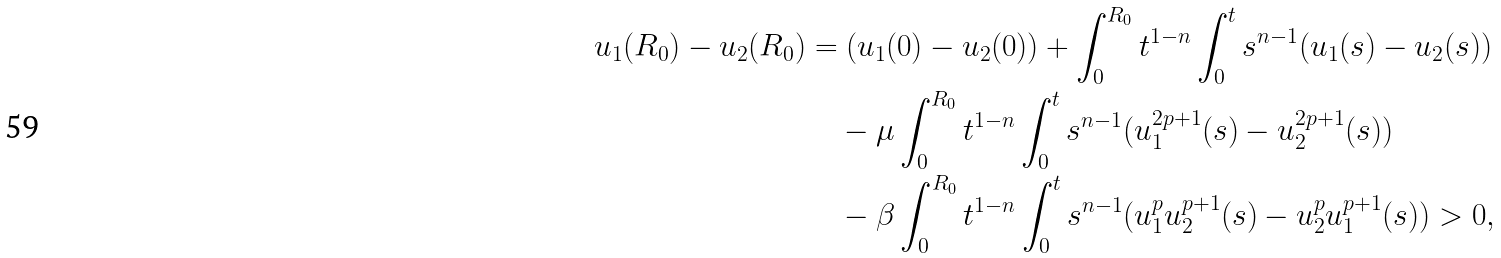<formula> <loc_0><loc_0><loc_500><loc_500>u _ { 1 } ( R _ { 0 } ) - u _ { 2 } ( R _ { 0 } ) & = ( u _ { 1 } ( 0 ) - u _ { 2 } ( 0 ) ) + \int _ { 0 } ^ { R _ { 0 } } t ^ { 1 - n } \int _ { 0 } ^ { t } s ^ { n - 1 } ( u _ { 1 } ( s ) - u _ { 2 } ( s ) ) \\ & \quad - \mu \int _ { 0 } ^ { R _ { 0 } } t ^ { 1 - n } \int _ { 0 } ^ { t } s ^ { n - 1 } ( u _ { 1 } ^ { 2 p + 1 } ( s ) - u _ { 2 } ^ { 2 p + 1 } ( s ) ) \\ & \quad - \beta \int _ { 0 } ^ { R _ { 0 } } t ^ { 1 - n } \int _ { 0 } ^ { t } s ^ { n - 1 } ( u _ { 1 } ^ { p } u _ { 2 } ^ { p + 1 } ( s ) - u _ { 2 } ^ { p } u _ { 1 } ^ { p + 1 } ( s ) ) > 0 ,</formula> 